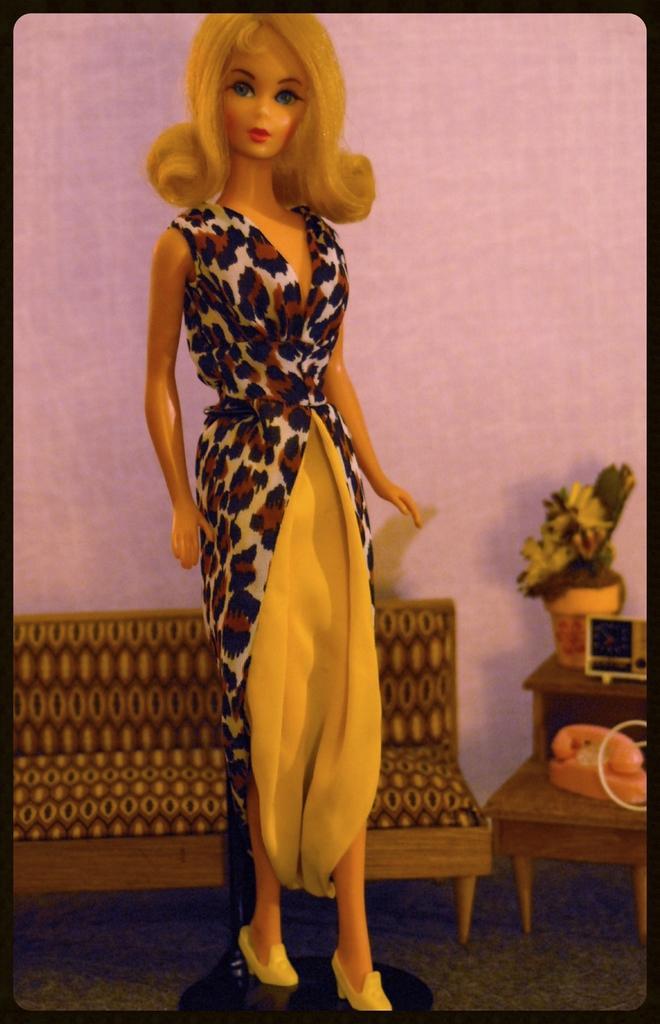Describe this image in one or two sentences. In this image in the center there is a doll, and in the background there is a chair, stool, phone, flower pot and object and there is a wall. At the bottom there is floor. 